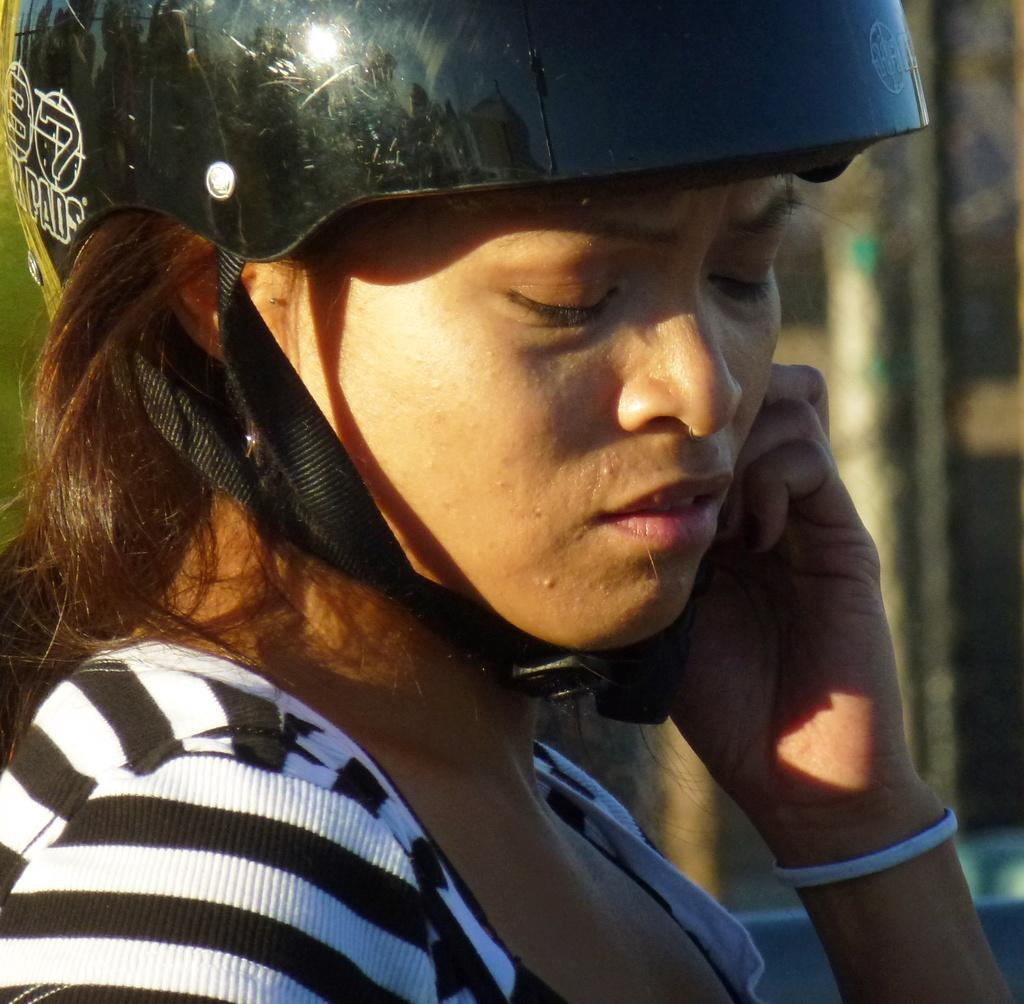Who is present in the image? There is a woman in the image. What is the woman wearing on her head? The woman is wearing a helmet. Can you describe the background of the image? The background of the image is blurry. What type of door can be seen in the image? There is no door present in the image. What color is the powder that the woman is holding in the image? There is no powder or any indication of the woman holding anything in the image. 